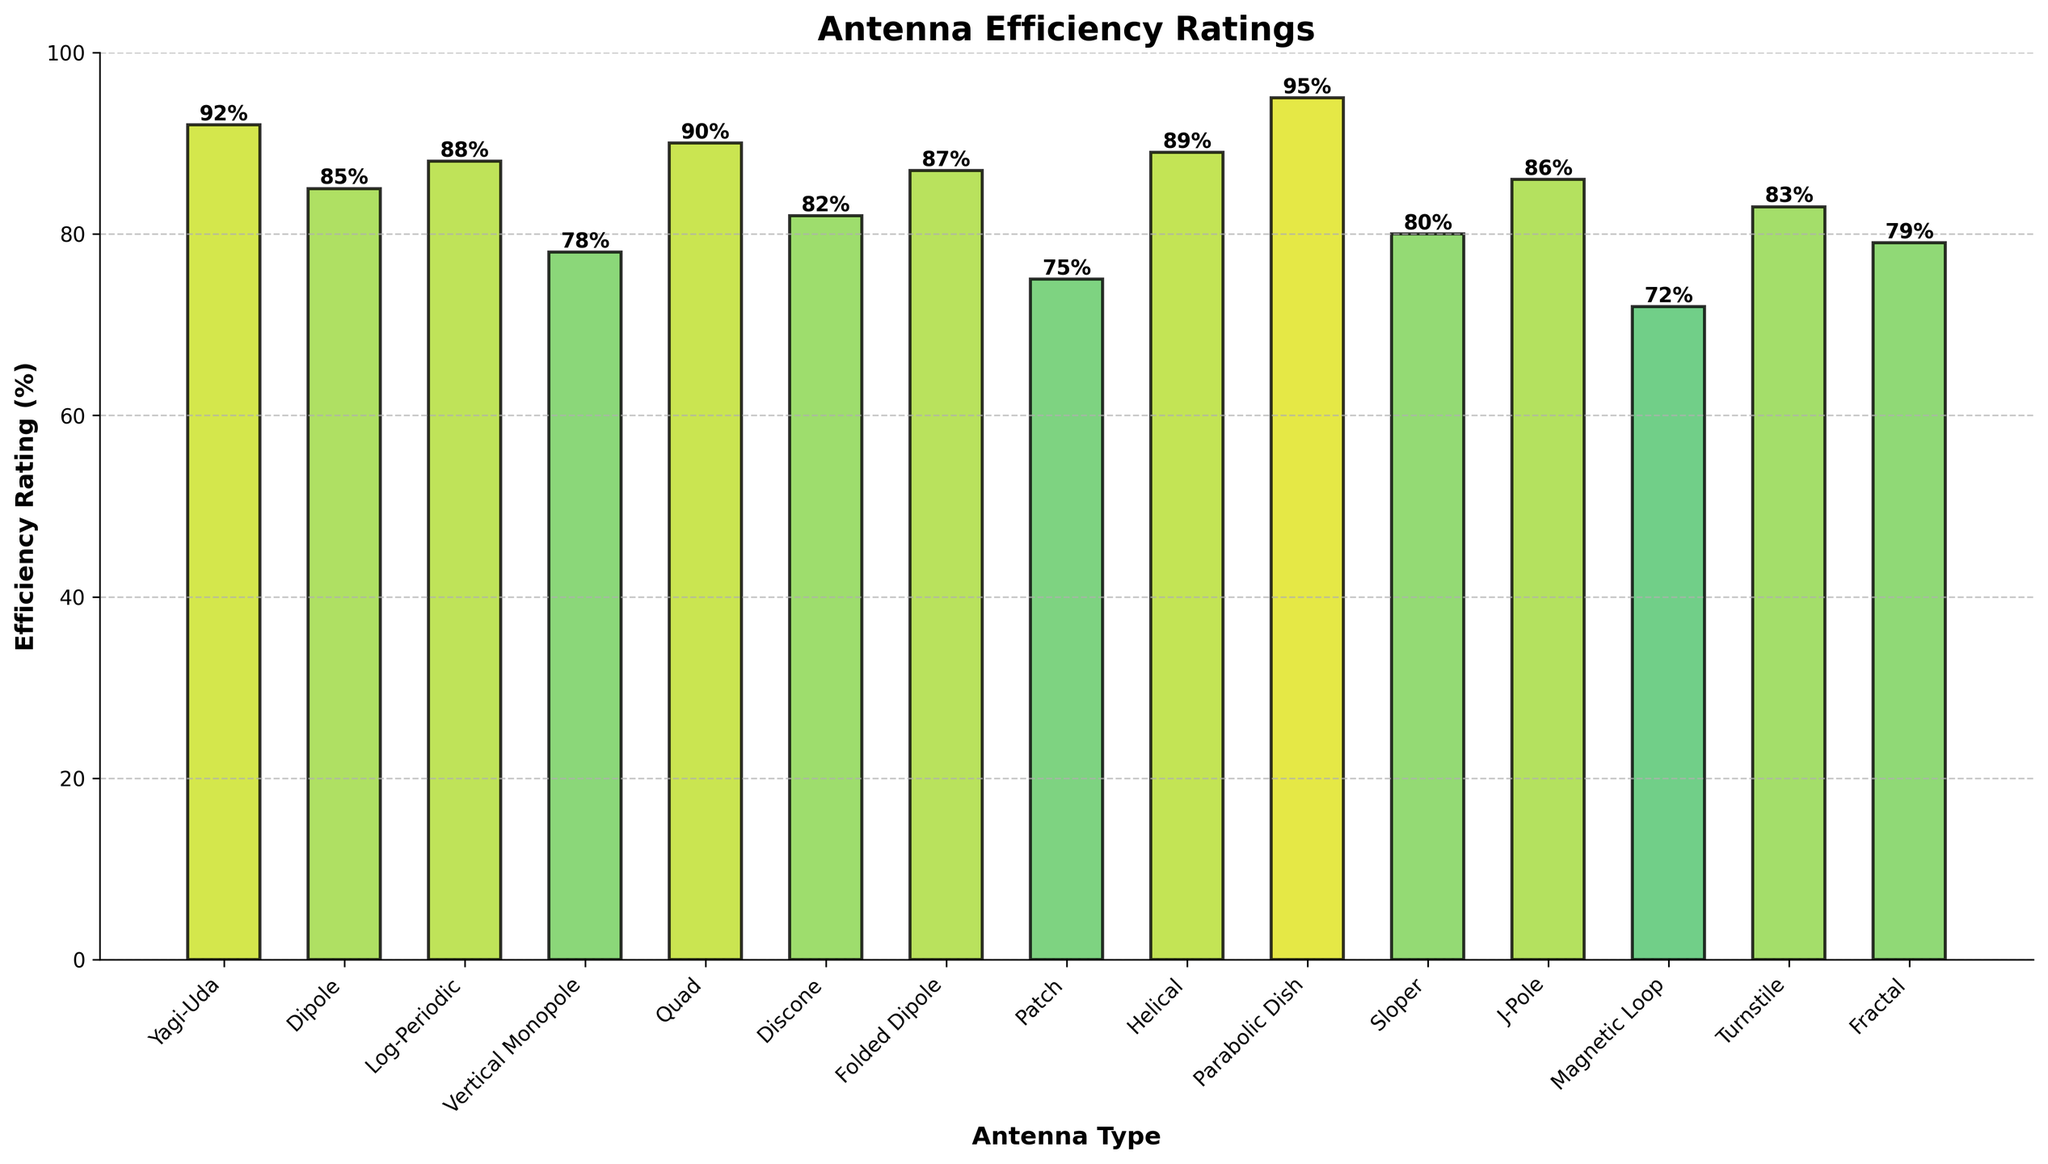What's the highest efficiency rating among the antenna types? Locate the bar that reaches the highest point on the y-axis, which corresponds to the highest efficiency rating. The 'Parabolic Dish' has the tallest bar, indicating the highest rating.
Answer: 95% Which antenna type has an efficiency rating of 75%? Find the bar that has an associated height of 75% on the y-axis. The 'Patch' antenna has this efficiency rating.
Answer: Patch How many antenna types have an efficiency rating greater than 85%? Count all the bars that extend beyond the 85% mark on the y-axis. There are six bars (Yagi-Uda, Log-Periodic, Quad, Folded Dipole, Helical, Parabolic Dish).
Answer: 6 Compare the efficiency ratings of 'Yagi-Uda' and 'Vertical Monopole'. Which is higher and by how much? Identify the heights of the two bars: 'Yagi-Uda' at 92% and 'Vertical Monopole' at 78%. Calculate the difference, 92% - 78% = 14%.
Answer: Yagi-Uda by 14% What is the average efficiency rating of 'Dipole', 'Folded Dipole', and 'Sloper' antennas? First, identify the ratings: Dipole (85%), Folded Dipole (87%), and Sloper (80%). Sum these ratings (85 + 87 + 80 = 252) and divide by the number of items (3). The average is 252 / 3 = 84%.
Answer: 84% Identify the antenna types with efficiency ratings below 80%. Look for bars with heights below the 80% mark on the y-axis, which are 'Vertical Monopole', 'Patch', 'Magnetic Loop', and 'Fractal'.
Answer: Vertical Monopole, Patch, Magnetic Loop, Fractal Which antenna type has the longest frequency range as indicated in the x-axis labels? The 'Parabolic Dish' has the longest range (1000-10000 MHz) as stated in its label.
Answer: Parabolic Dish How many antenna types have efficiency ratings between 80% and 90% inclusive? Count the bars whose heights fall between 80% and 90% inclusive. There are six such bars (Log-Periodic, Quad, Folded Dipole, Helical, Sloper, J-Pole, and Turnstile).
Answer: 7 